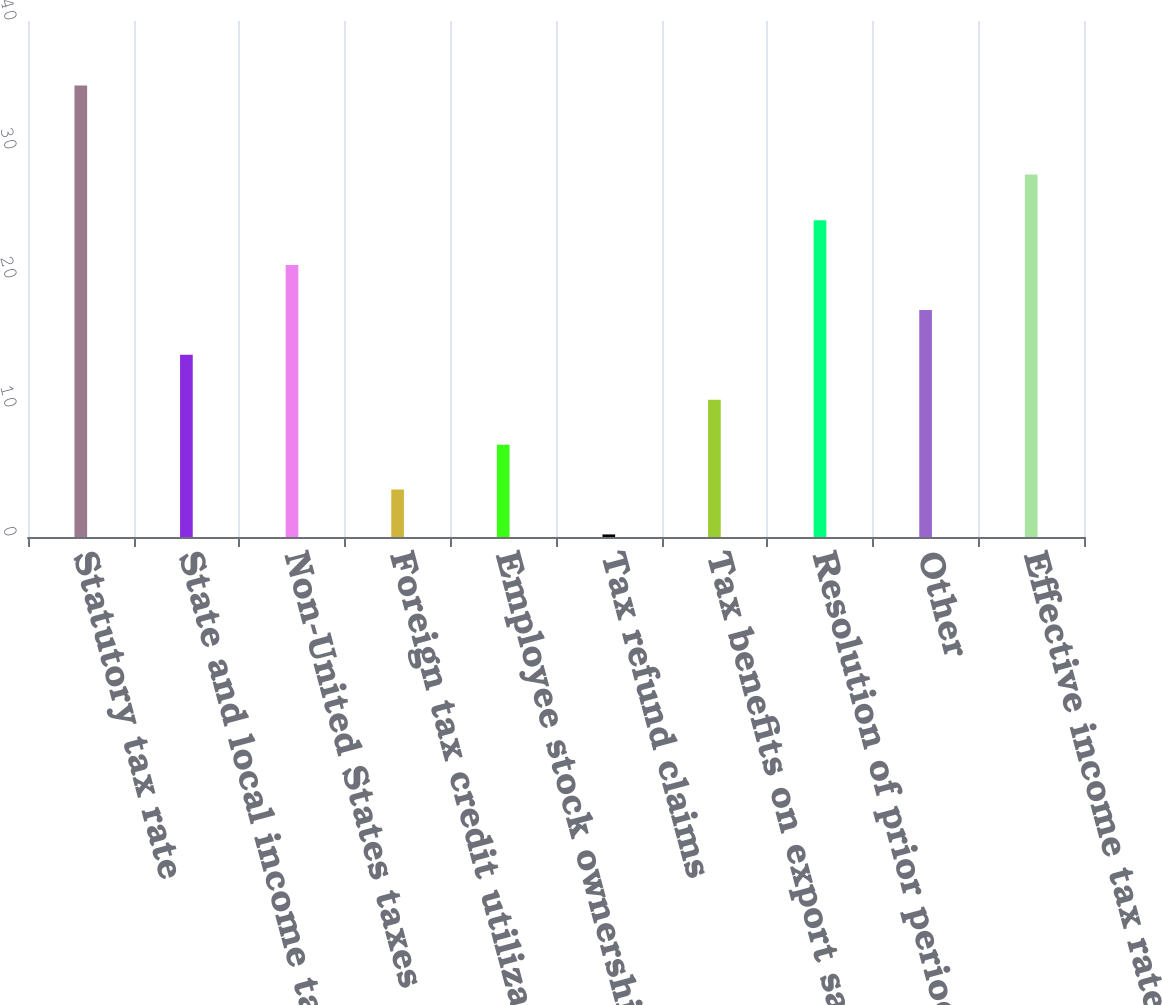Convert chart to OTSL. <chart><loc_0><loc_0><loc_500><loc_500><bar_chart><fcel>Statutory tax rate<fcel>State and local income taxes<fcel>Non-United States taxes<fcel>Foreign tax credit utilization<fcel>Employee stock ownership plan<fcel>Tax refund claims<fcel>Tax benefits on export sales<fcel>Resolution of prior period tax<fcel>Other<fcel>Effective income tax rate<nl><fcel>35<fcel>14.12<fcel>21.08<fcel>3.68<fcel>7.16<fcel>0.2<fcel>10.64<fcel>24.56<fcel>17.6<fcel>28.1<nl></chart> 